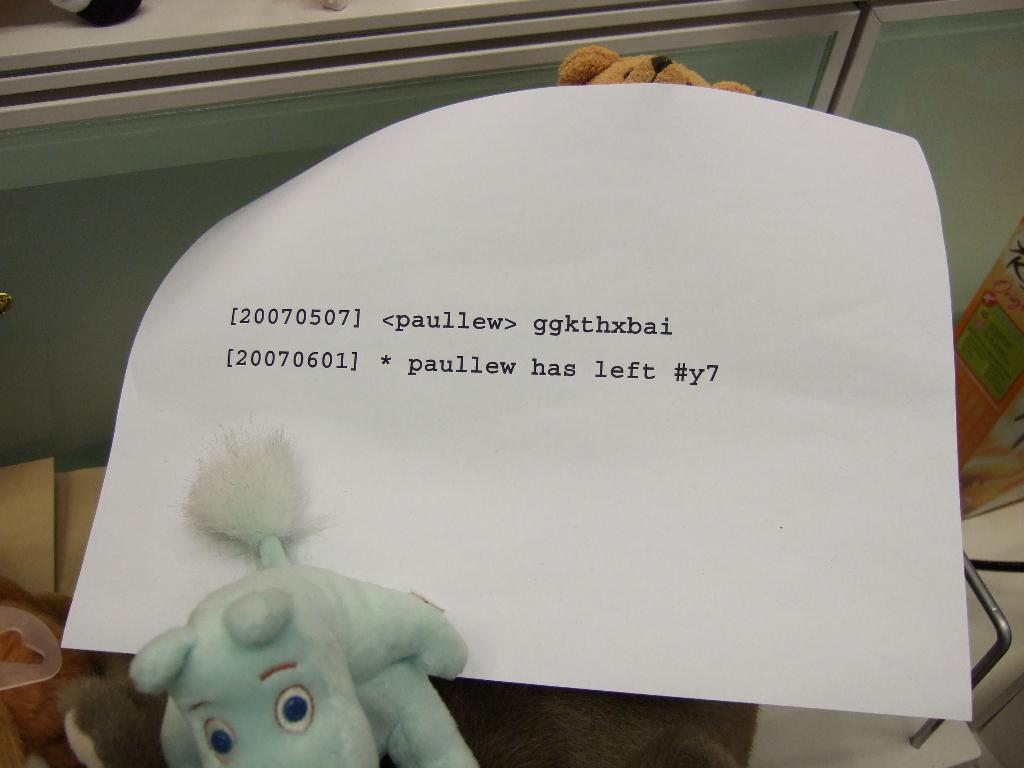What is present on the paper in the image? The paper has text on it. What other items can be seen in the image besides the paper? There are toys and other objects in the image. What type of surface is visible in the image? There is a floor visible in the image. Can you see a jellyfish swimming on the floor in the image? No, there is no jellyfish present in the image. 